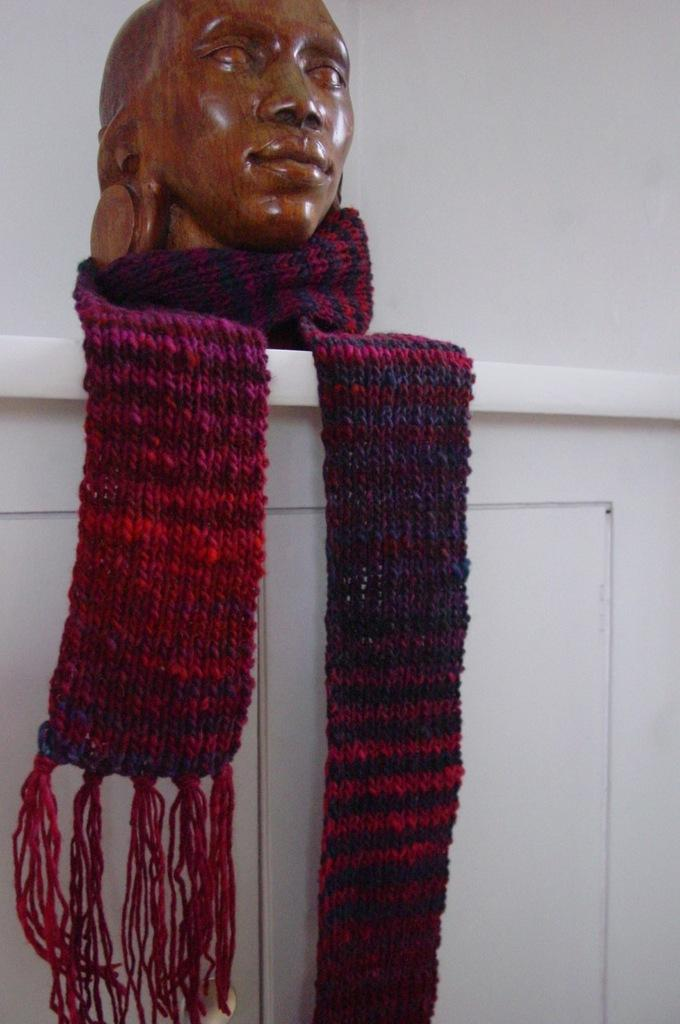What type of artwork is featured in the image? There is a wooden sculpture in the image. What is draped over an object in the image? There is a scarf on an object in the image. What color is the background of the image? The background of the image is white. What type of jam is being spread on the hair in the image? There is no jam or hair present in the image; it only features a wooden sculpture and a scarf on an object. 